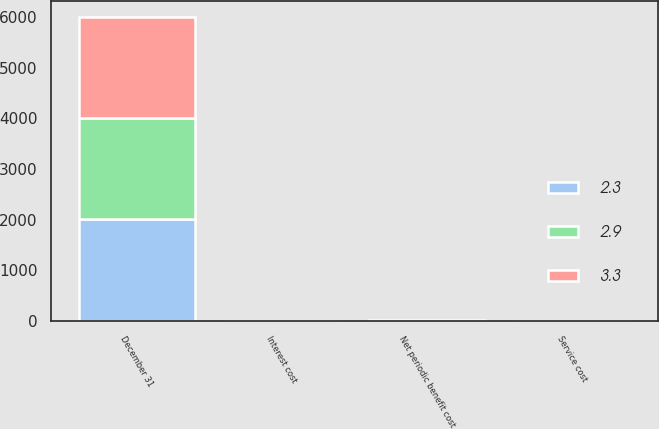Convert chart. <chart><loc_0><loc_0><loc_500><loc_500><stacked_bar_chart><ecel><fcel>December 31<fcel>Service cost<fcel>Interest cost<fcel>Net periodic benefit cost<nl><fcel>2.9<fcel>2004<fcel>1.4<fcel>1.7<fcel>3.3<nl><fcel>3.3<fcel>2003<fcel>1.3<fcel>1.5<fcel>2.9<nl><fcel>2.3<fcel>2002<fcel>1.1<fcel>1.2<fcel>2.3<nl></chart> 